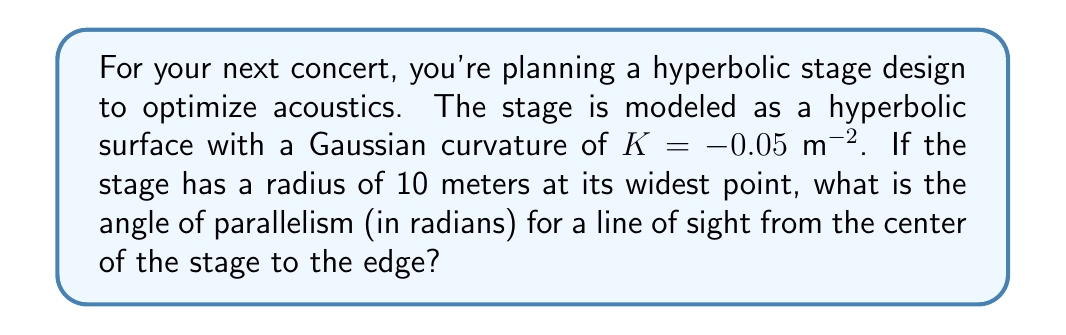Can you solve this math problem? To solve this problem, we'll use concepts from hyperbolic geometry:

1) In hyperbolic geometry, the angle of parallelism $\Pi(d)$ for a distance $d$ is given by:

   $$\Pi(d) = 2 \arctan(e^{-d\sqrt{|K|}})$$

2) We're given the Gaussian curvature $K = -0.05$ m^{-2}$ and the radius $r = 10$ m.

3) In hyperbolic geometry, the distance $d$ from the center to a point on a circle of radius $r$ is given by:

   $$d = \frac{1}{\sqrt{|K|}} \text{arcsinh}(r\sqrt{|K|})$$

4) Let's calculate $d$:
   
   $$d = \frac{1}{\sqrt{0.05}} \text{arcsinh}(10\sqrt{0.05})$$
   $$d \approx 10.0499 \text{ m}$$

5) Now we can calculate the angle of parallelism:

   $$\Pi(d) = 2 \arctan(e^{-10.0499\sqrt{0.05}})$$
   $$\Pi(d) \approx 0.4934 \text{ radians}$$

This angle represents the limiting angle at which parallel lines appear to diverge in this hyperbolic space, which is crucial for understanding sight lines and acoustic paths on your stage.
Answer: $0.4934$ radians 